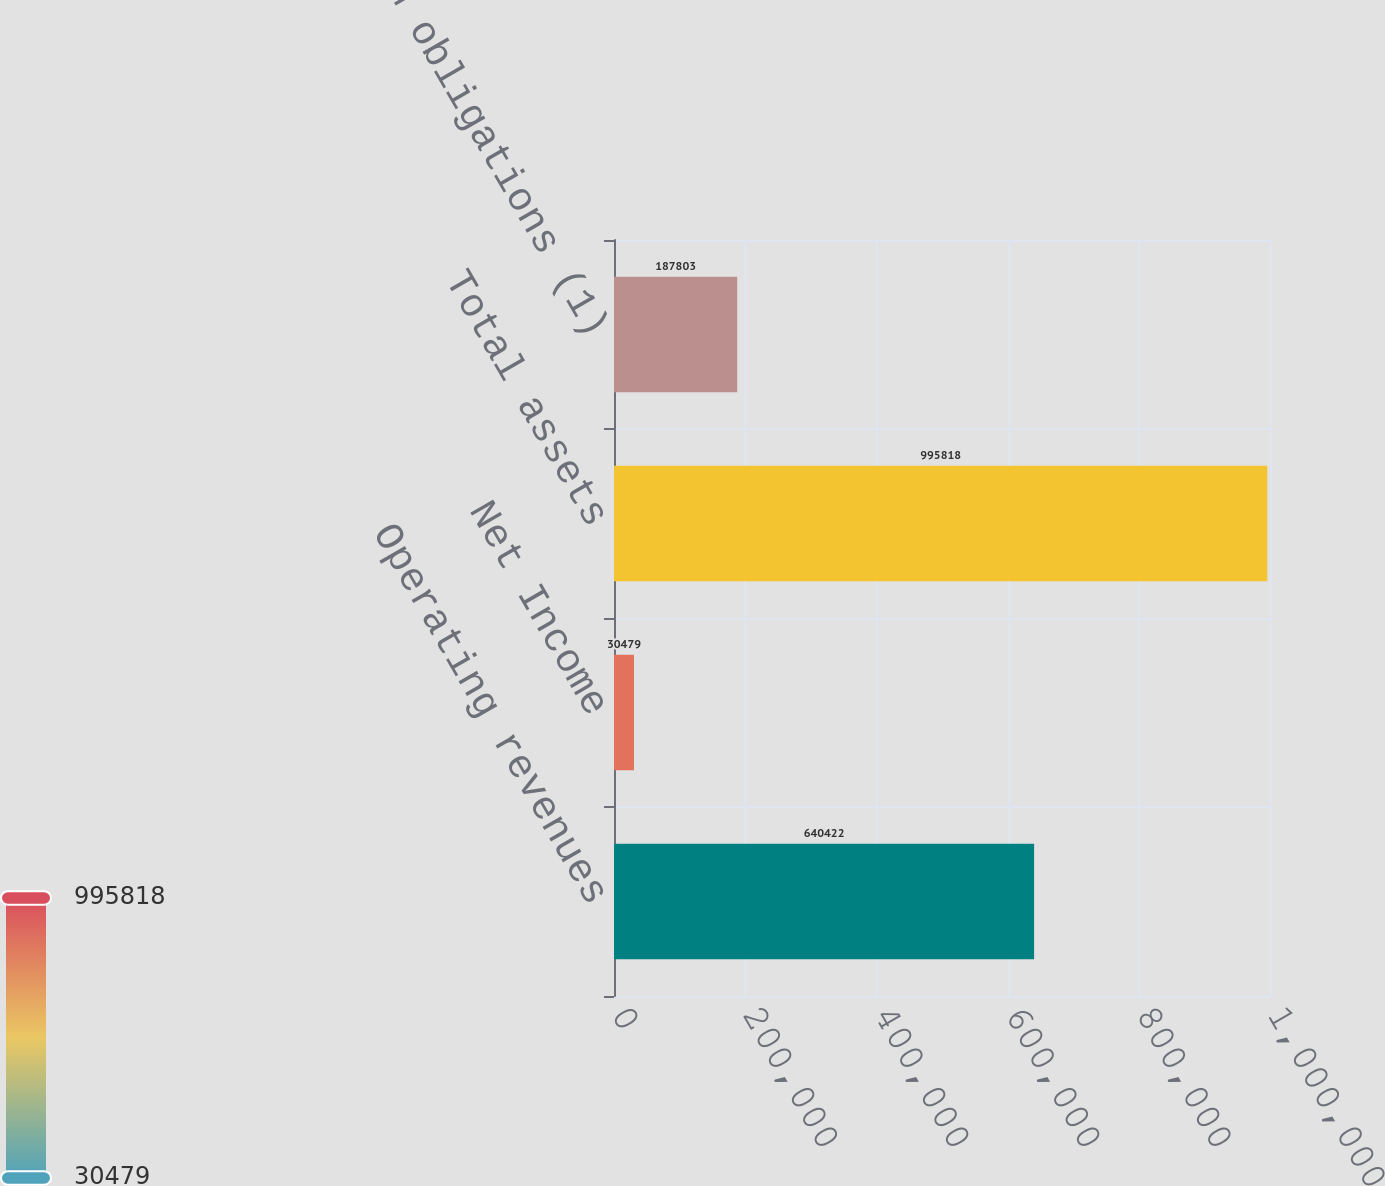Convert chart. <chart><loc_0><loc_0><loc_500><loc_500><bar_chart><fcel>Operating revenues<fcel>Net Income<fcel>Total assets<fcel>Long-term obligations (1)<nl><fcel>640422<fcel>30479<fcel>995818<fcel>187803<nl></chart> 